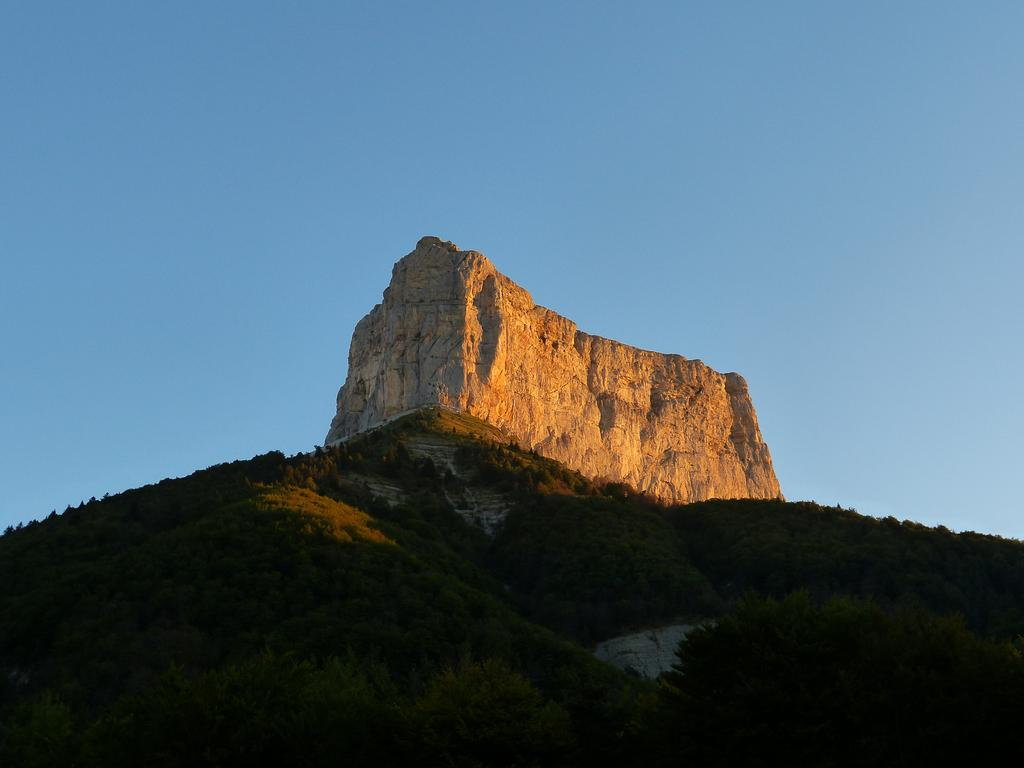What type of vegetation can be seen in the image? There is a group of trees in the image. What natural landforms are visible in the image? There are mountains in the image. What part of the natural environment is visible in the background of the image? The sky is visible in the background of the image. What type of garden can be seen in the image? There is no garden present in the image; it features a group of trees and mountains. What type of bubble is visible in the image? There is no bubble present in the image. 